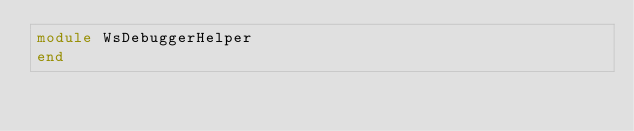<code> <loc_0><loc_0><loc_500><loc_500><_Ruby_>module WsDebuggerHelper
end
</code> 